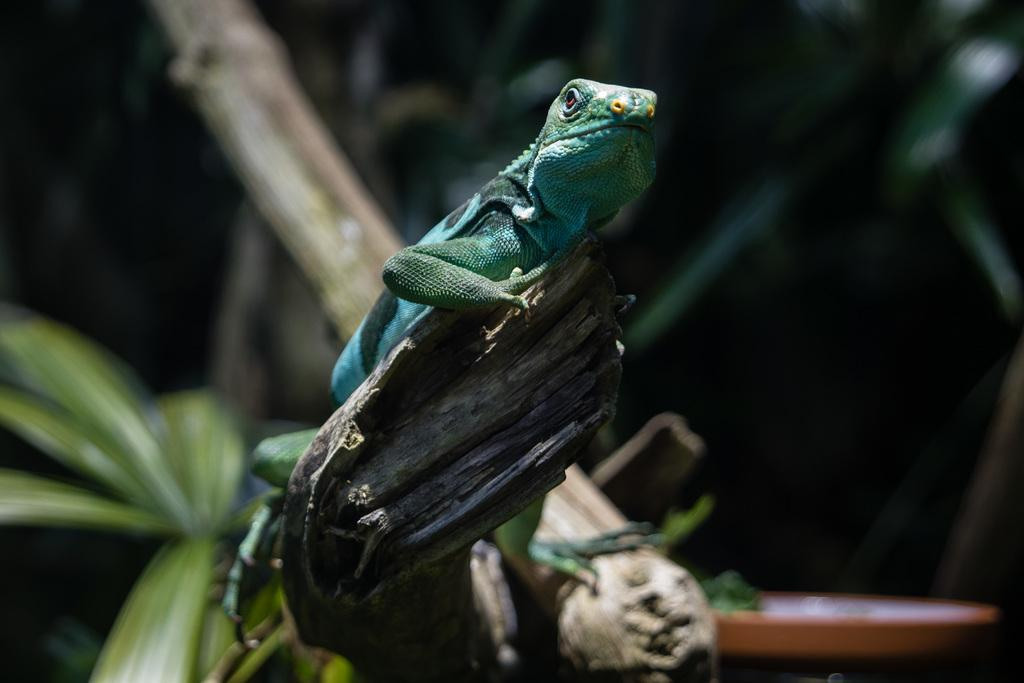What type of animal is in the image? There is a garden lizard in the image. Where is the garden lizard located? The garden lizard is on a branch. What can be seen in the background of the image? There are leaves and a flower pot visible in the background. What type of plant is the garden lizard using to form a bead necklace in the image? There is no plant, form, or bead necklace present in the image; it features a garden lizard on a branch with leaves and a flower pot in the background. 